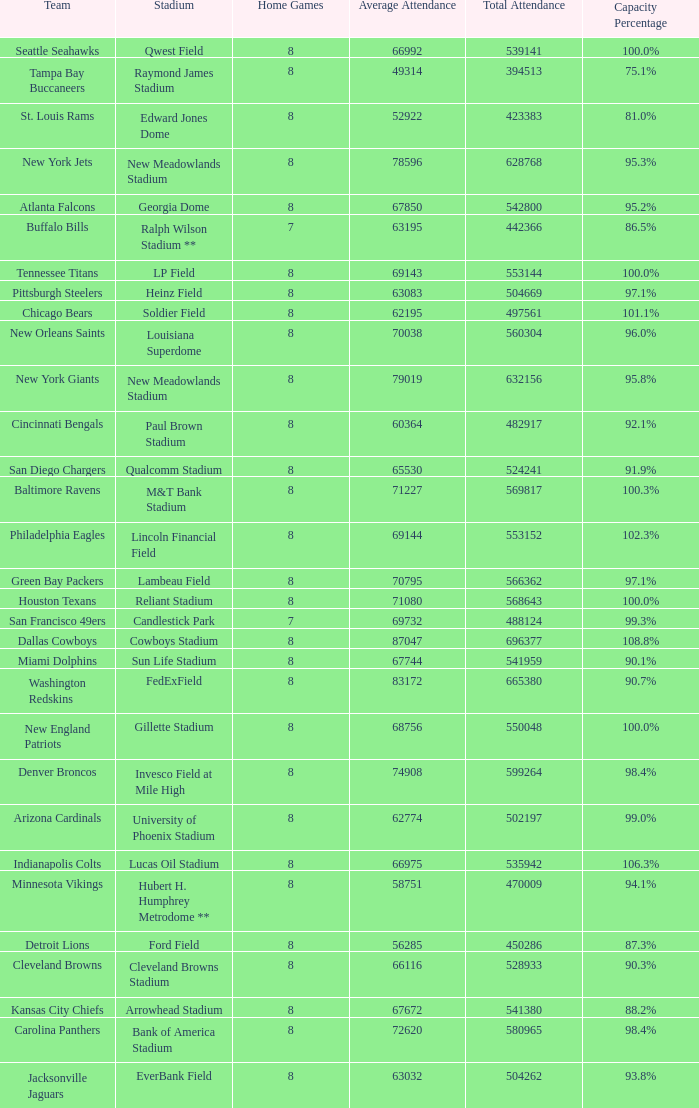What was the capacity percentage when attendance was 71080? 100.0%. 